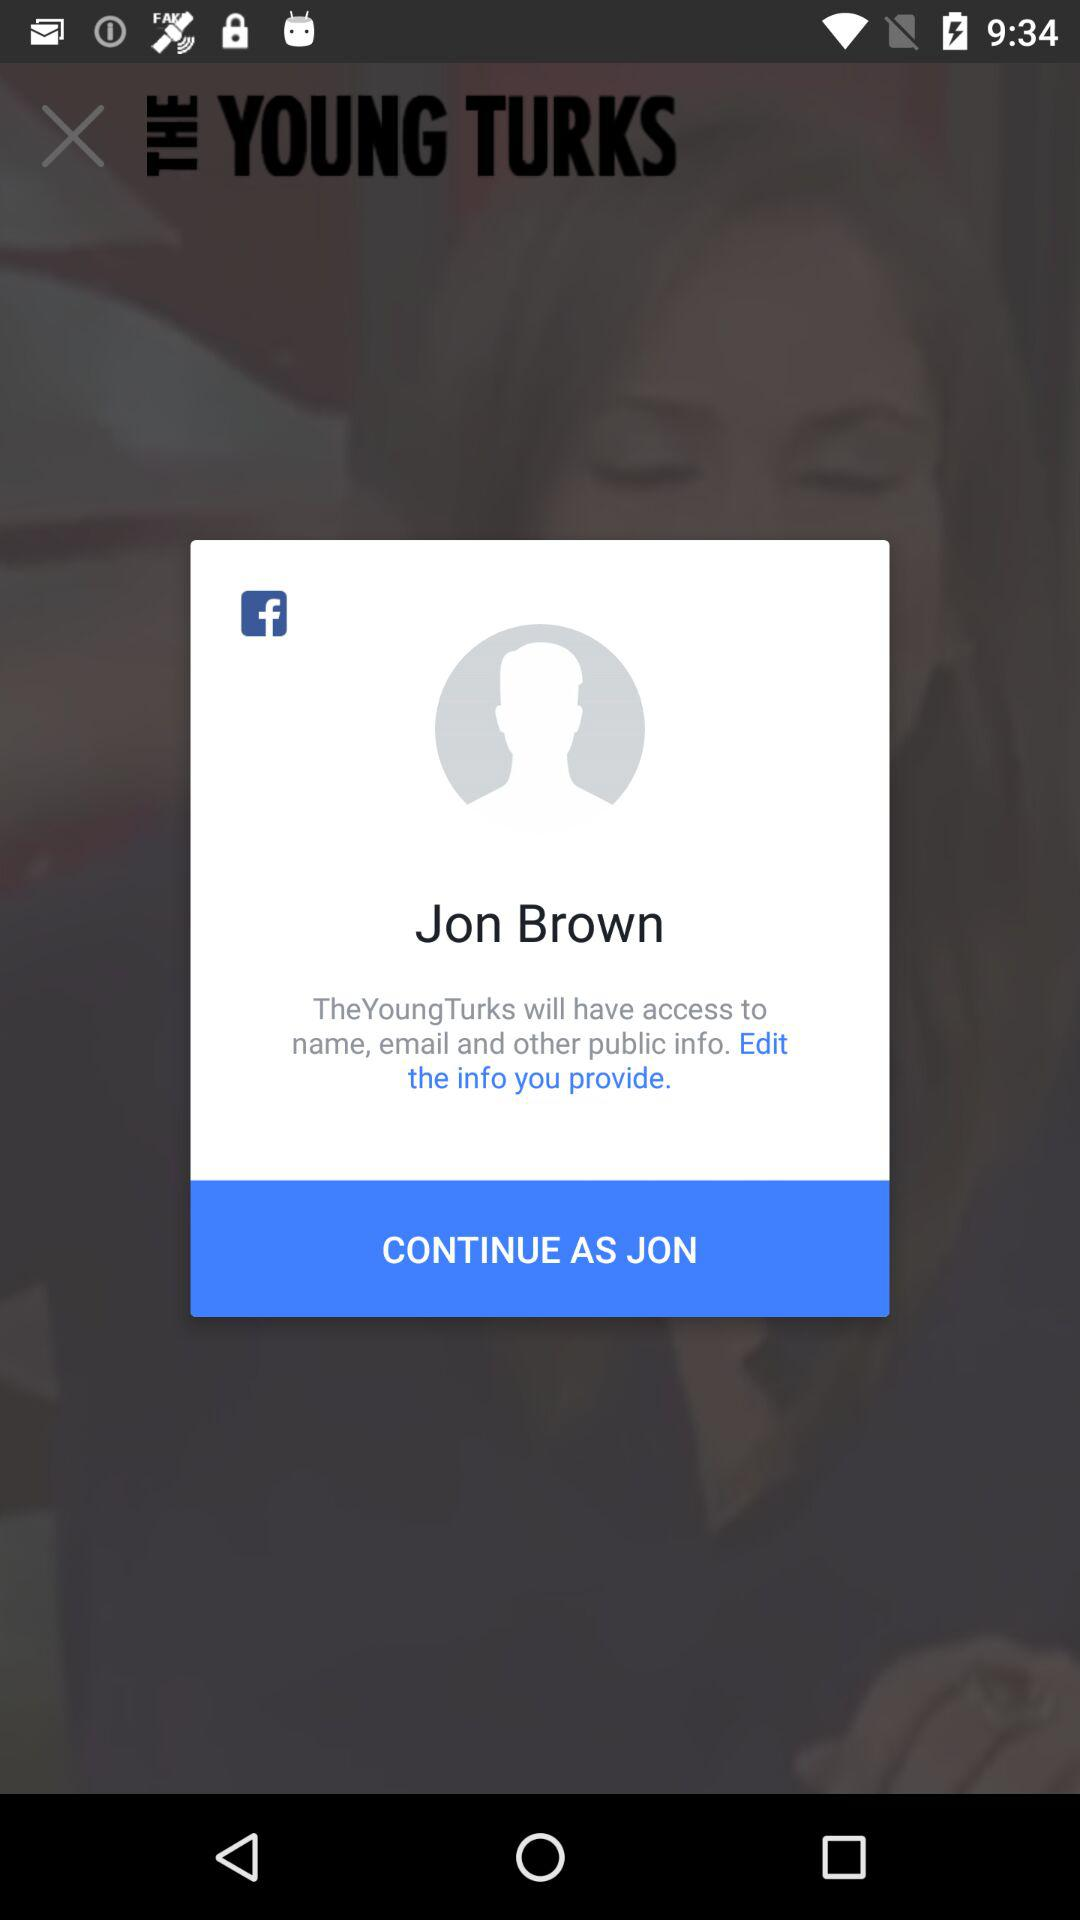What application has asked for permission? The application is "TheYoungTurks". 